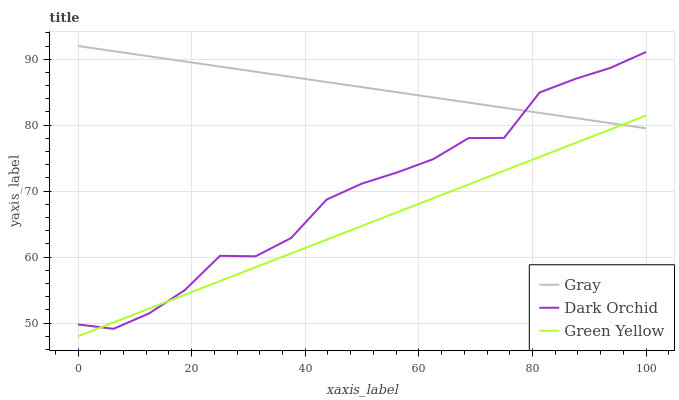Does Green Yellow have the minimum area under the curve?
Answer yes or no. Yes. Does Gray have the maximum area under the curve?
Answer yes or no. Yes. Does Dark Orchid have the minimum area under the curve?
Answer yes or no. No. Does Dark Orchid have the maximum area under the curve?
Answer yes or no. No. Is Gray the smoothest?
Answer yes or no. Yes. Is Dark Orchid the roughest?
Answer yes or no. Yes. Is Green Yellow the smoothest?
Answer yes or no. No. Is Green Yellow the roughest?
Answer yes or no. No. Does Green Yellow have the lowest value?
Answer yes or no. Yes. Does Dark Orchid have the lowest value?
Answer yes or no. No. Does Gray have the highest value?
Answer yes or no. Yes. Does Dark Orchid have the highest value?
Answer yes or no. No. Does Green Yellow intersect Gray?
Answer yes or no. Yes. Is Green Yellow less than Gray?
Answer yes or no. No. Is Green Yellow greater than Gray?
Answer yes or no. No. 